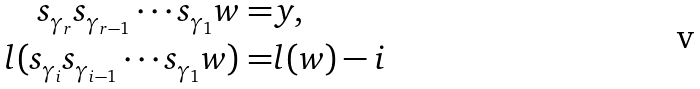<formula> <loc_0><loc_0><loc_500><loc_500>s _ { \gamma _ { r } } s _ { \gamma _ { r - 1 } } \cdots s _ { \gamma _ { 1 } } w = & y , \\ l ( s _ { \gamma _ { i } } s _ { \gamma _ { i - 1 } } \cdots s _ { \gamma _ { 1 } } w ) = & l ( w ) - i</formula> 